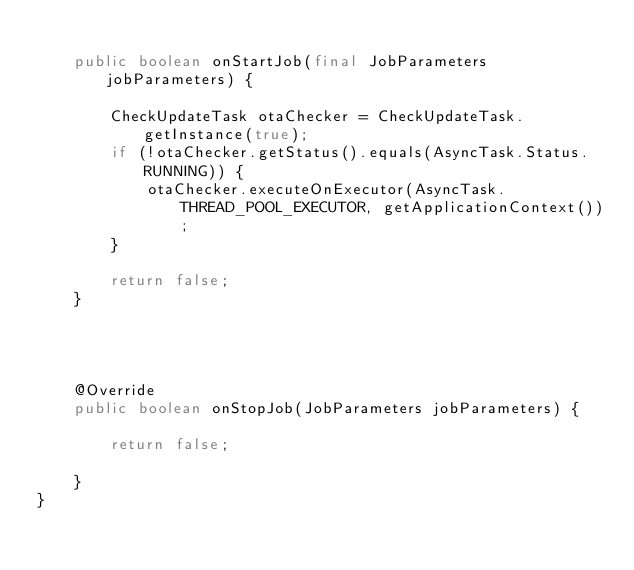<code> <loc_0><loc_0><loc_500><loc_500><_Java_>
    public boolean onStartJob(final JobParameters jobParameters) {

        CheckUpdateTask otaChecker = CheckUpdateTask.getInstance(true);
        if (!otaChecker.getStatus().equals(AsyncTask.Status.RUNNING)) {
            otaChecker.executeOnExecutor(AsyncTask.THREAD_POOL_EXECUTOR, getApplicationContext());
        }

        return false;
    }




    @Override
    public boolean onStopJob(JobParameters jobParameters) {

        return false;

    }
}
</code> 